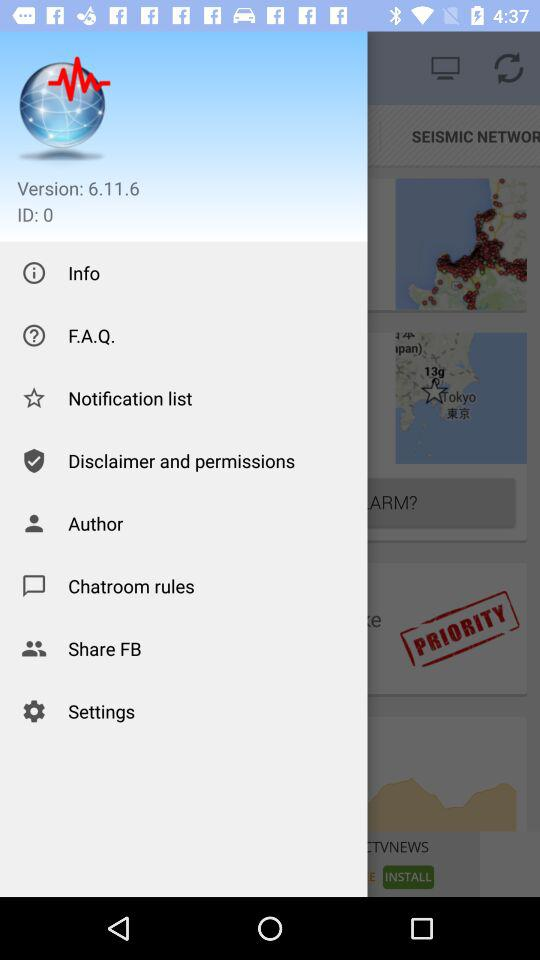What is the ID? The ID is 0. 